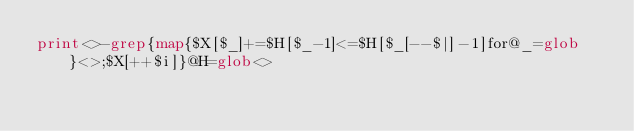<code> <loc_0><loc_0><loc_500><loc_500><_Perl_>print<>-grep{map{$X[$_]+=$H[$_-1]<=$H[$_[--$|]-1]for@_=glob}<>;$X[++$i]}@H=glob<></code> 